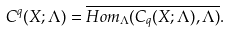Convert formula to latex. <formula><loc_0><loc_0><loc_500><loc_500>C ^ { q } ( X ; \Lambda ) = \overline { H o m _ { \Lambda } ( C _ { q } ( X ; \Lambda ) , \Lambda ) } .</formula> 